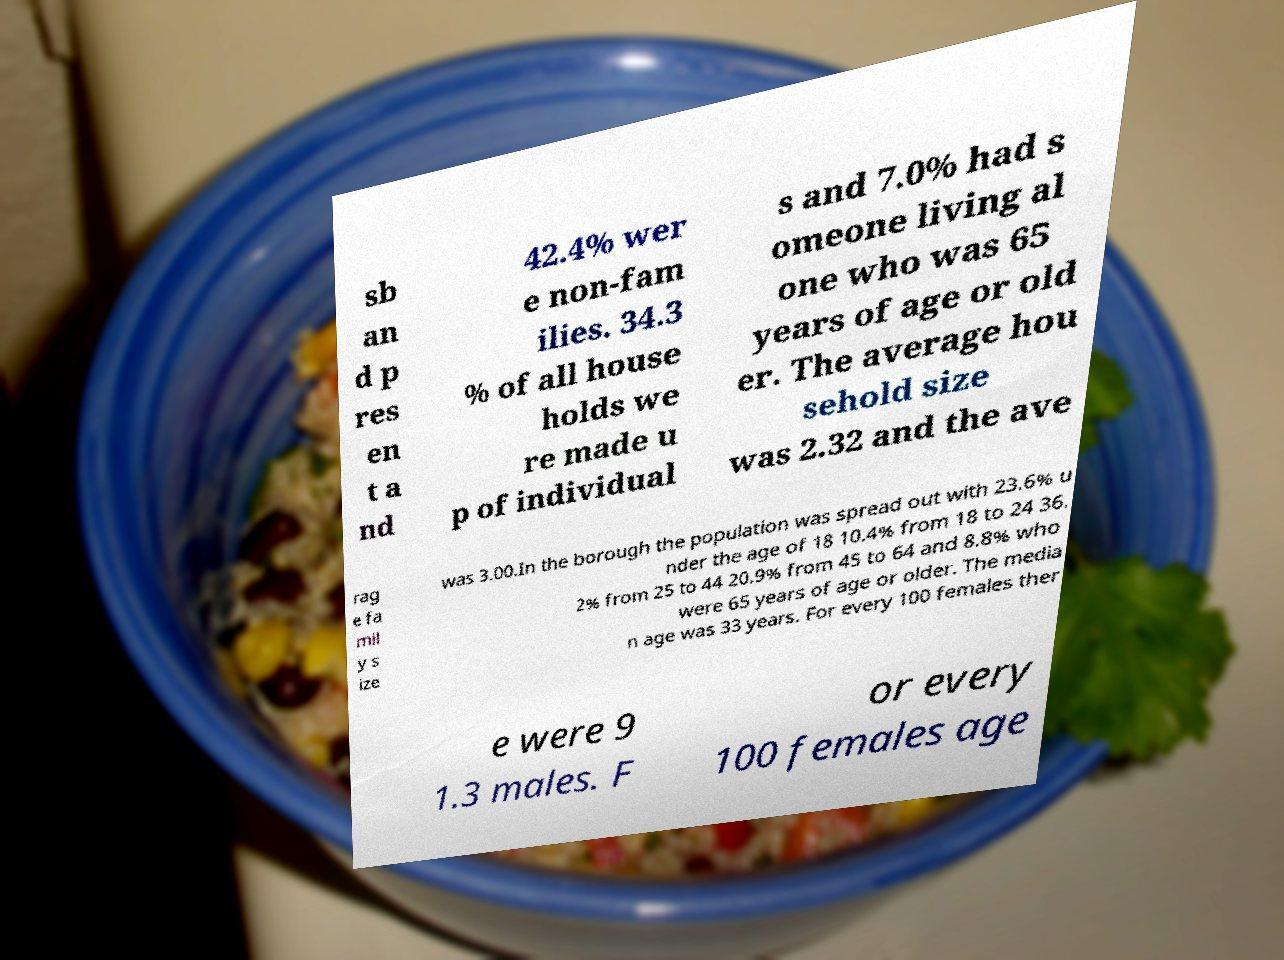Could you extract and type out the text from this image? sb an d p res en t a nd 42.4% wer e non-fam ilies. 34.3 % of all house holds we re made u p of individual s and 7.0% had s omeone living al one who was 65 years of age or old er. The average hou sehold size was 2.32 and the ave rag e fa mil y s ize was 3.00.In the borough the population was spread out with 23.6% u nder the age of 18 10.4% from 18 to 24 36. 2% from 25 to 44 20.9% from 45 to 64 and 8.8% who were 65 years of age or older. The media n age was 33 years. For every 100 females ther e were 9 1.3 males. F or every 100 females age 